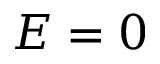Convert formula to latex. <formula><loc_0><loc_0><loc_500><loc_500>E = 0</formula> 